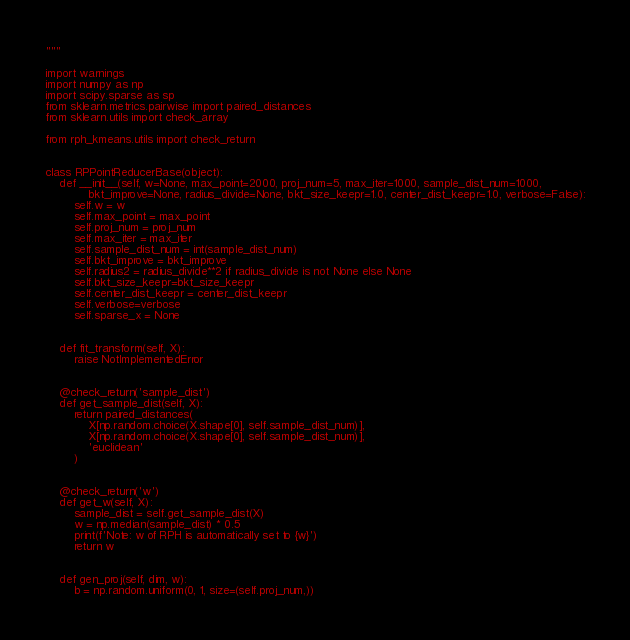Convert code to text. <code><loc_0><loc_0><loc_500><loc_500><_Python_>"""

import warnings
import numpy as np
import scipy.sparse as sp
from sklearn.metrics.pairwise import paired_distances
from sklearn.utils import check_array

from rph_kmeans.utils import check_return


class RPPointReducerBase(object):
	def __init__(self, w=None, max_point=2000, proj_num=5, max_iter=1000, sample_dist_num=1000,
			bkt_improve=None, radius_divide=None, bkt_size_keepr=1.0, center_dist_keepr=1.0, verbose=False):
		self.w = w
		self.max_point = max_point
		self.proj_num = proj_num
		self.max_iter = max_iter
		self.sample_dist_num = int(sample_dist_num)
		self.bkt_improve = bkt_improve
		self.radius2 = radius_divide**2 if radius_divide is not None else None
		self.bkt_size_keepr=bkt_size_keepr
		self.center_dist_keepr = center_dist_keepr
		self.verbose=verbose
		self.sparse_x = None


	def fit_transform(self, X):
		raise NotImplementedError


	@check_return('sample_dist')
	def get_sample_dist(self, X):
		return paired_distances(
			X[np.random.choice(X.shape[0], self.sample_dist_num)],
			X[np.random.choice(X.shape[0], self.sample_dist_num)],
			'euclidean'
		)


	@check_return('w')
	def get_w(self, X):
		sample_dist = self.get_sample_dist(X)
		w = np.median(sample_dist) * 0.5
		print(f'Note: w of RPH is automatically set to {w}')
		return w


	def gen_proj(self, dim, w):
		b = np.random.uniform(0, 1, size=(self.proj_num,))</code> 